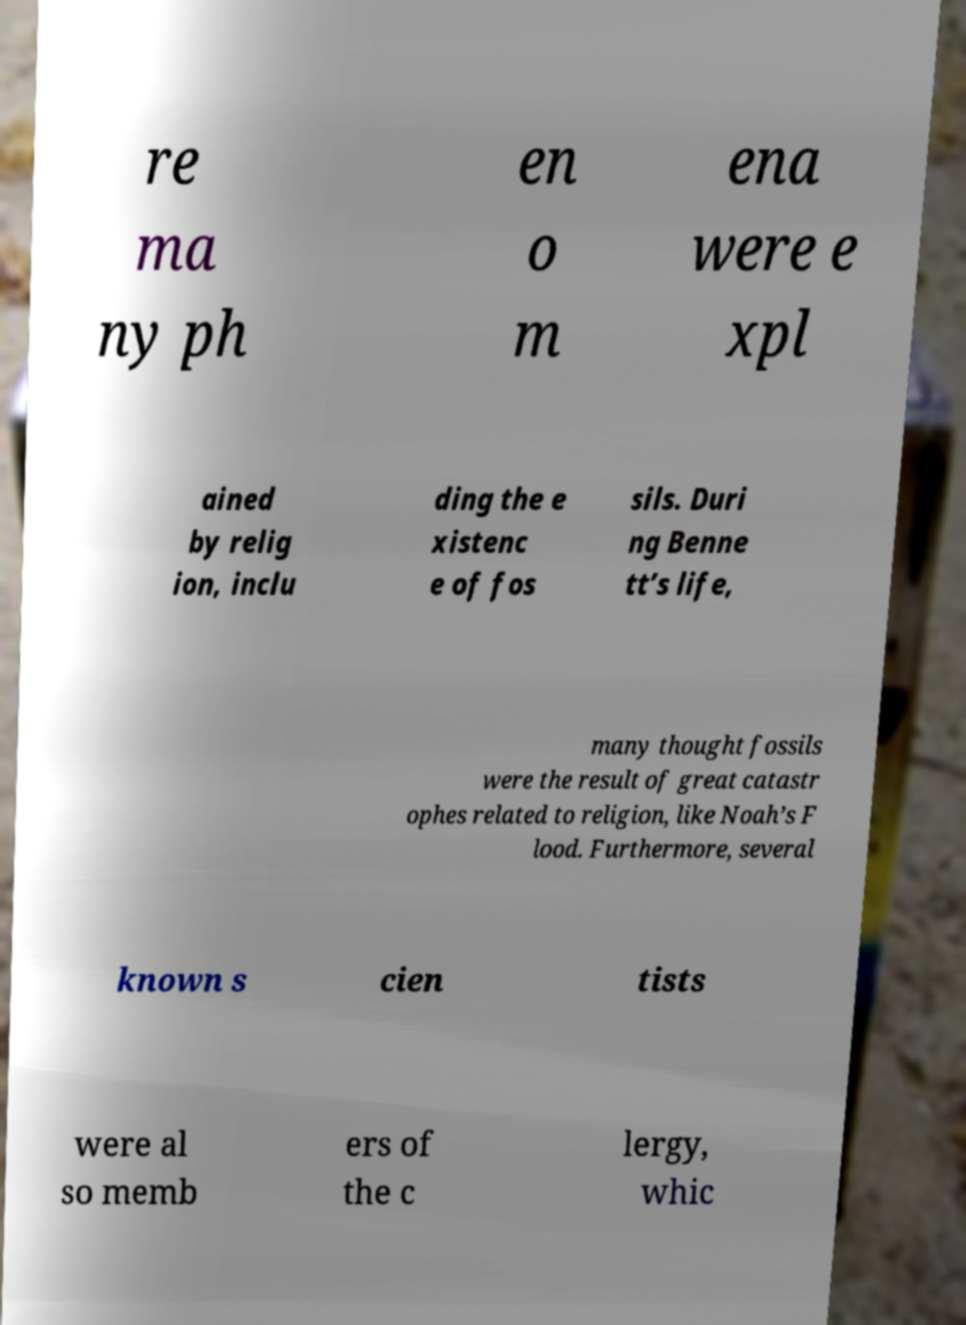What messages or text are displayed in this image? I need them in a readable, typed format. re ma ny ph en o m ena were e xpl ained by relig ion, inclu ding the e xistenc e of fos sils. Duri ng Benne tt’s life, many thought fossils were the result of great catastr ophes related to religion, like Noah’s F lood. Furthermore, several known s cien tists were al so memb ers of the c lergy, whic 